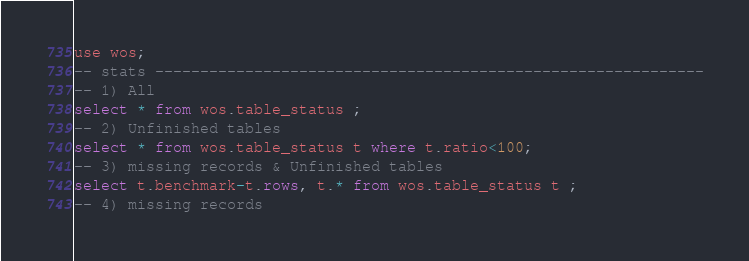<code> <loc_0><loc_0><loc_500><loc_500><_SQL_>use wos;
-- stats -------------------------------------------------------------
-- 1) All
select * from wos.table_status ;
-- 2) Unfinished tables
select * from wos.table_status t where t.ratio<100;
-- 3) missing records & Unfinished tables
select t.benchmark-t.rows, t.* from wos.table_status t ;
-- 4) missing records</code> 